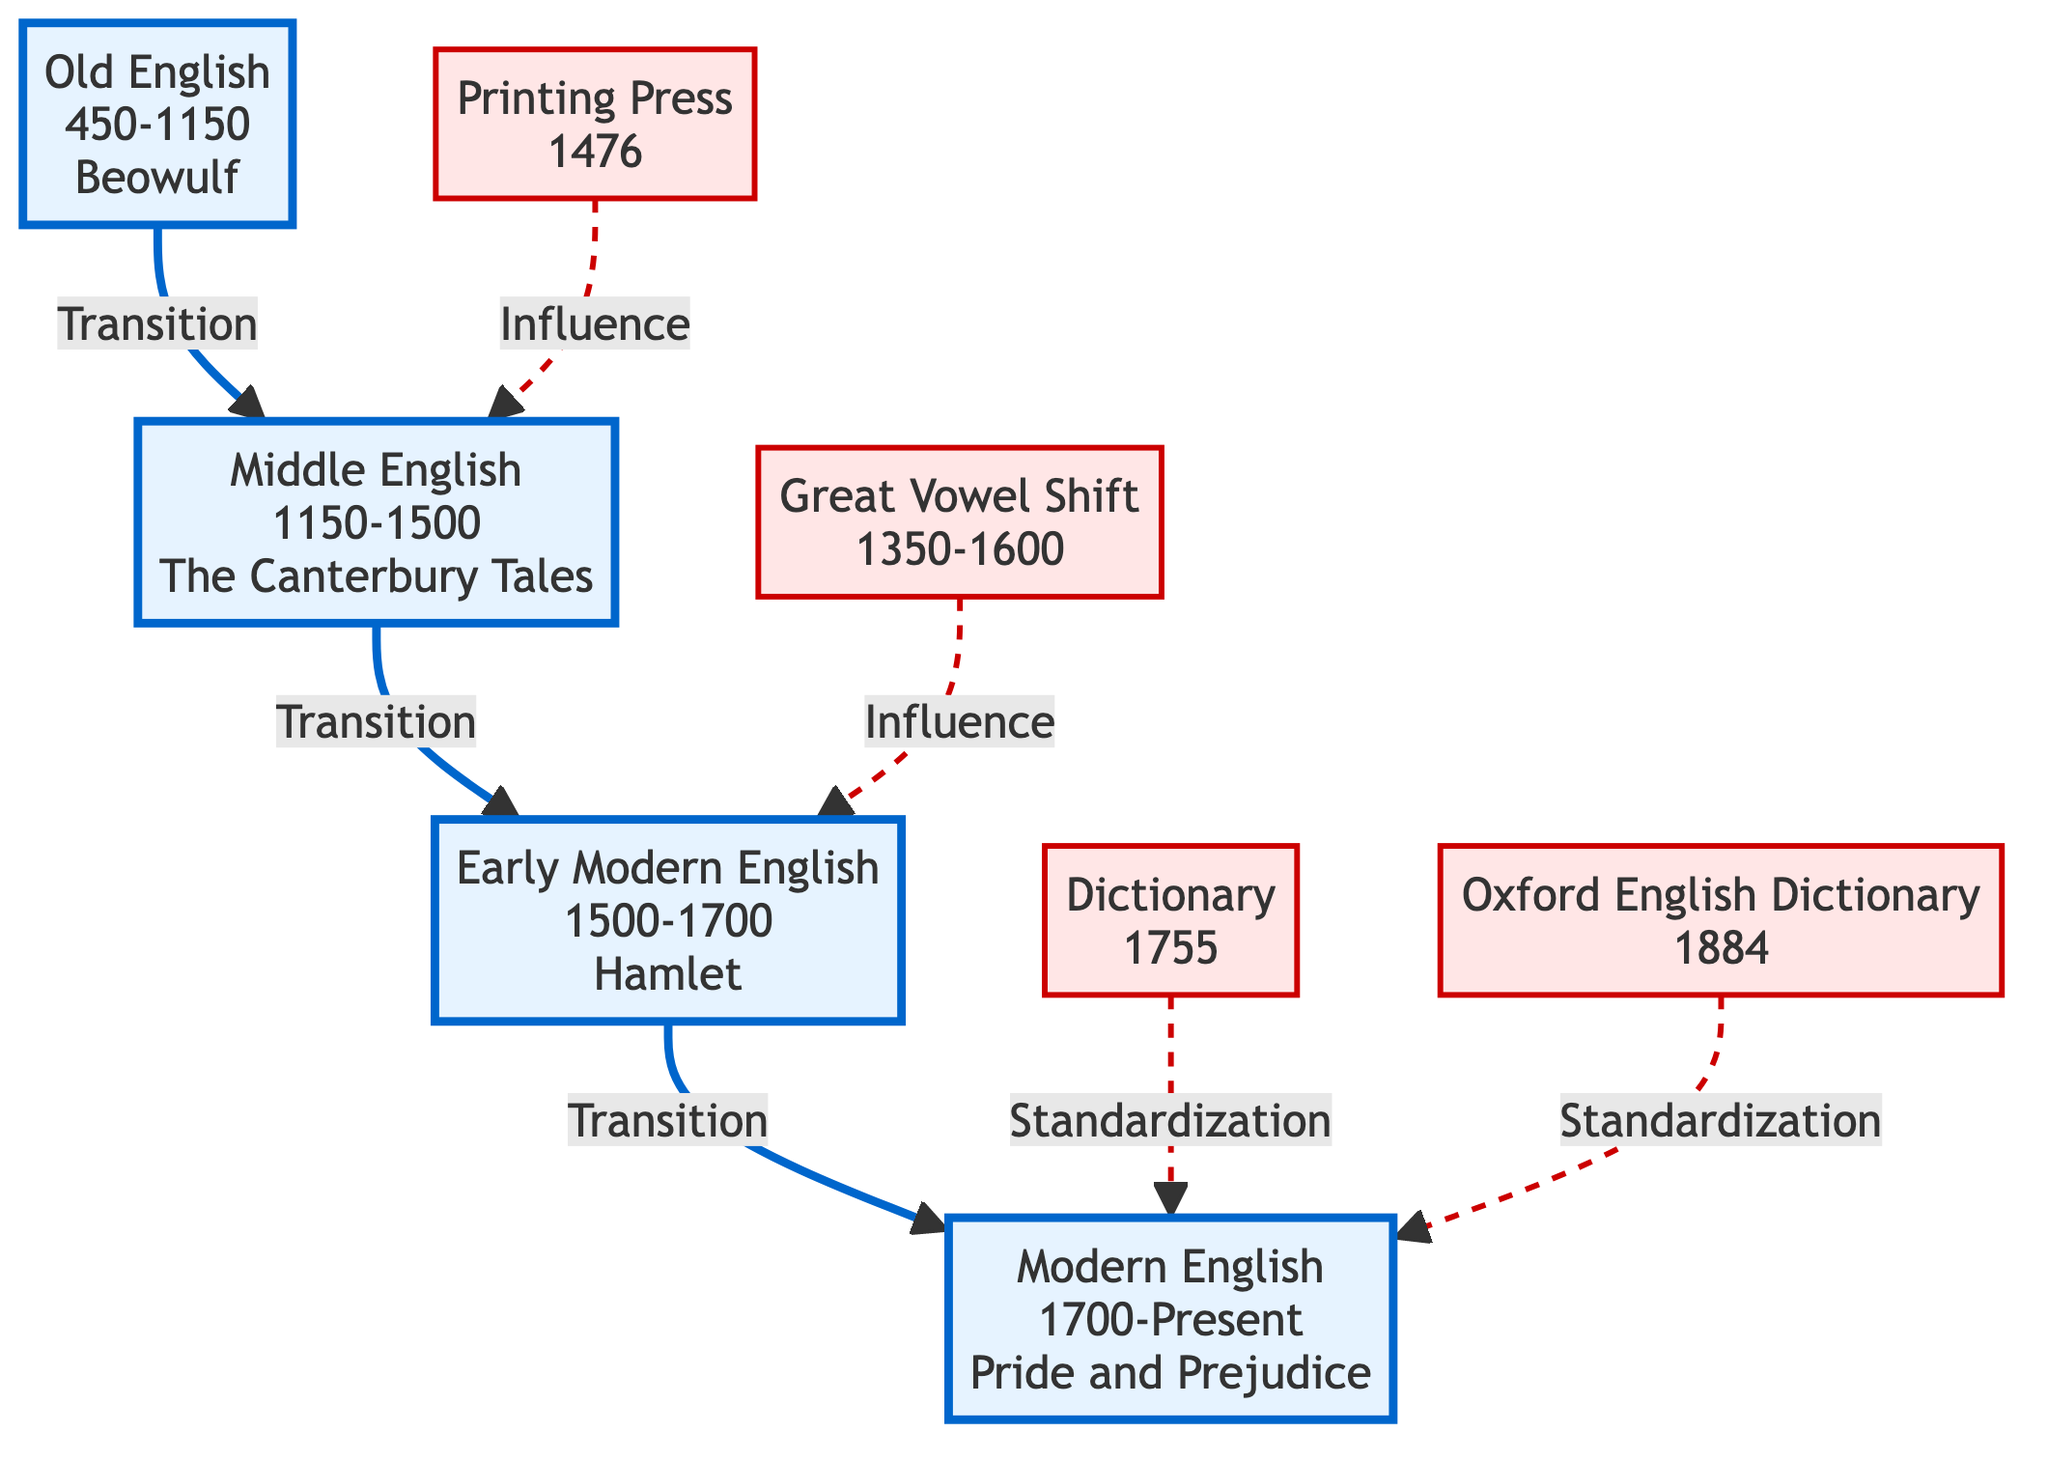What is the earliest era of the English language depicted? The diagram shows "Old English" as the earliest era, which is represented in the diagram with the label "OE." This node specifies the years 450-1150 and is also associated with the work "Beowulf."
Answer: Old English Which influential work is associated with Middle English? The diagram points to "The Canterbury Tales" as the key work for the Middle English period, labeled under the node "ME." This label also indicates the years 1150-1500, confirming its relevance during this era.
Answer: The Canterbury Tales What year does the Great Vowel Shift begin? In the diagram, the Great Vowel Shift is marked with a starting year of 1350. It is a significant milestone leading to the Early Modern English period.
Answer: 1350 How many eras of the English language are depicted in the diagram? The diagram includes four distinct eras, starting with Old English and ending with Modern English. Each era is visually separated, and only four are present in total.
Answer: 4 Which milestone is linked to the standardization of Modern English? The diagram lists "Dictionary" (1755) and "Oxford English Dictionary" (1884) as milestones that are connected to the standardization of Modern English, showing their importance in this process.
Answer: Dictionary, Oxford English Dictionary What is the transition that occurs from Early Modern English? The flow in the diagram shows that the transition from Early Modern English (denoted as EME) leads to Modern English (ModE), indicating a direct progression.
Answer: Modern English What impact did the Printing Press have on Middle English? The diagram indicates that the Printing Press, introduced in 1476, had an influence on the development of Middle English as signified by the arrow connecting these nodes.
Answer: Influence Which node represents the final stage of the evolution of the English language? The last node in the diagram is "Modern English," which starts from 1700 and is the concluding stage in the evolution outlined. This indicates its contemporary status.
Answer: Modern English What is the time range of Early Modern English? According to the diagram, Early Modern English spans from the year 1500 to 1700, as shown in the node labeled "EME."
Answer: 1500-1700 